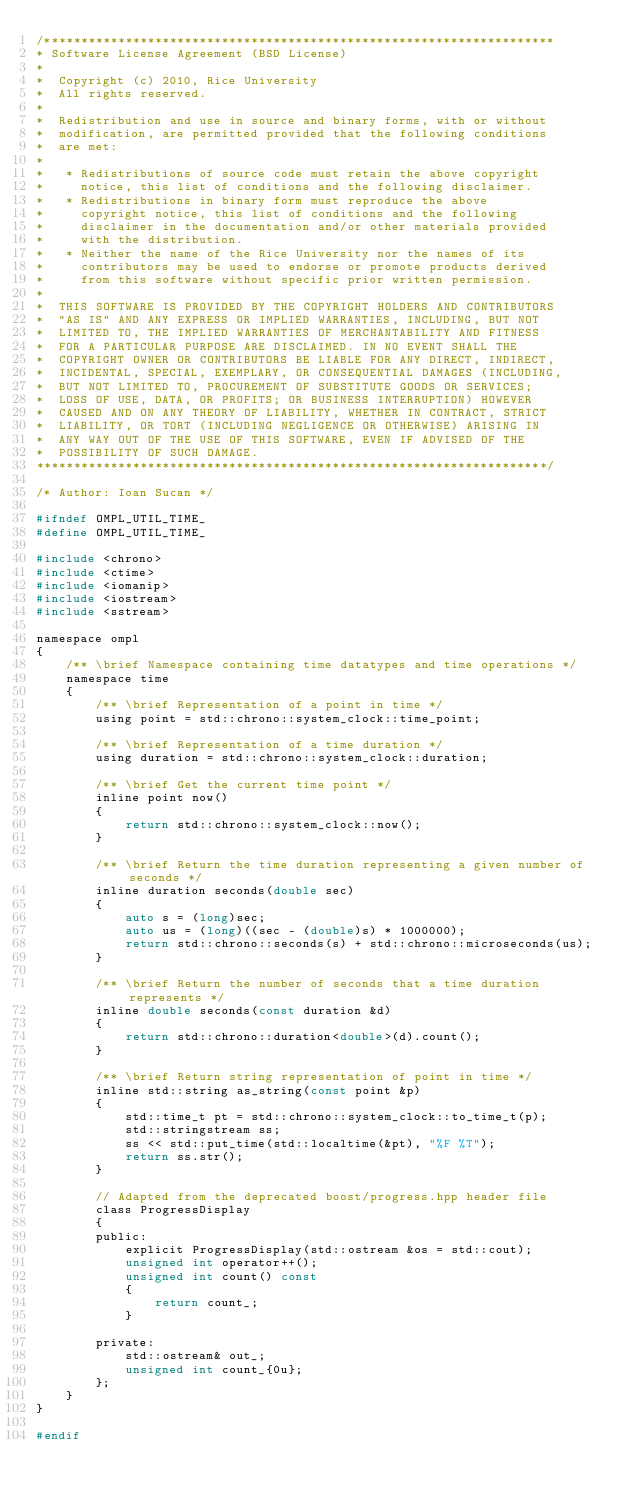<code> <loc_0><loc_0><loc_500><loc_500><_C_>/*********************************************************************
* Software License Agreement (BSD License)
*
*  Copyright (c) 2010, Rice University
*  All rights reserved.
*
*  Redistribution and use in source and binary forms, with or without
*  modification, are permitted provided that the following conditions
*  are met:
*
*   * Redistributions of source code must retain the above copyright
*     notice, this list of conditions and the following disclaimer.
*   * Redistributions in binary form must reproduce the above
*     copyright notice, this list of conditions and the following
*     disclaimer in the documentation and/or other materials provided
*     with the distribution.
*   * Neither the name of the Rice University nor the names of its
*     contributors may be used to endorse or promote products derived
*     from this software without specific prior written permission.
*
*  THIS SOFTWARE IS PROVIDED BY THE COPYRIGHT HOLDERS AND CONTRIBUTORS
*  "AS IS" AND ANY EXPRESS OR IMPLIED WARRANTIES, INCLUDING, BUT NOT
*  LIMITED TO, THE IMPLIED WARRANTIES OF MERCHANTABILITY AND FITNESS
*  FOR A PARTICULAR PURPOSE ARE DISCLAIMED. IN NO EVENT SHALL THE
*  COPYRIGHT OWNER OR CONTRIBUTORS BE LIABLE FOR ANY DIRECT, INDIRECT,
*  INCIDENTAL, SPECIAL, EXEMPLARY, OR CONSEQUENTIAL DAMAGES (INCLUDING,
*  BUT NOT LIMITED TO, PROCUREMENT OF SUBSTITUTE GOODS OR SERVICES;
*  LOSS OF USE, DATA, OR PROFITS; OR BUSINESS INTERRUPTION) HOWEVER
*  CAUSED AND ON ANY THEORY OF LIABILITY, WHETHER IN CONTRACT, STRICT
*  LIABILITY, OR TORT (INCLUDING NEGLIGENCE OR OTHERWISE) ARISING IN
*  ANY WAY OUT OF THE USE OF THIS SOFTWARE, EVEN IF ADVISED OF THE
*  POSSIBILITY OF SUCH DAMAGE.
*********************************************************************/

/* Author: Ioan Sucan */

#ifndef OMPL_UTIL_TIME_
#define OMPL_UTIL_TIME_

#include <chrono>
#include <ctime>
#include <iomanip>
#include <iostream>
#include <sstream>

namespace ompl
{
    /** \brief Namespace containing time datatypes and time operations */
    namespace time
    {
        /** \brief Representation of a point in time */
        using point = std::chrono::system_clock::time_point;

        /** \brief Representation of a time duration */
        using duration = std::chrono::system_clock::duration;

        /** \brief Get the current time point */
        inline point now()
        {
            return std::chrono::system_clock::now();
        }

        /** \brief Return the time duration representing a given number of seconds */
        inline duration seconds(double sec)
        {
            auto s = (long)sec;
            auto us = (long)((sec - (double)s) * 1000000);
            return std::chrono::seconds(s) + std::chrono::microseconds(us);
        }

        /** \brief Return the number of seconds that a time duration represents */
        inline double seconds(const duration &d)
        {
            return std::chrono::duration<double>(d).count();
        }

        /** \brief Return string representation of point in time */
        inline std::string as_string(const point &p)
        {
            std::time_t pt = std::chrono::system_clock::to_time_t(p);
            std::stringstream ss;
            ss << std::put_time(std::localtime(&pt), "%F %T");
            return ss.str();
        }

        // Adapted from the deprecated boost/progress.hpp header file
        class ProgressDisplay
        {
        public:
            explicit ProgressDisplay(std::ostream &os = std::cout);
            unsigned int operator++();
            unsigned int count() const
            {
                return count_;
            }

        private:
            std::ostream& out_;
            unsigned int count_{0u};
        };
    }
}

#endif
</code> 